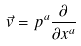<formula> <loc_0><loc_0><loc_500><loc_500>\vec { v } = p ^ { a } \frac { \partial } { \partial x ^ { a } }</formula> 